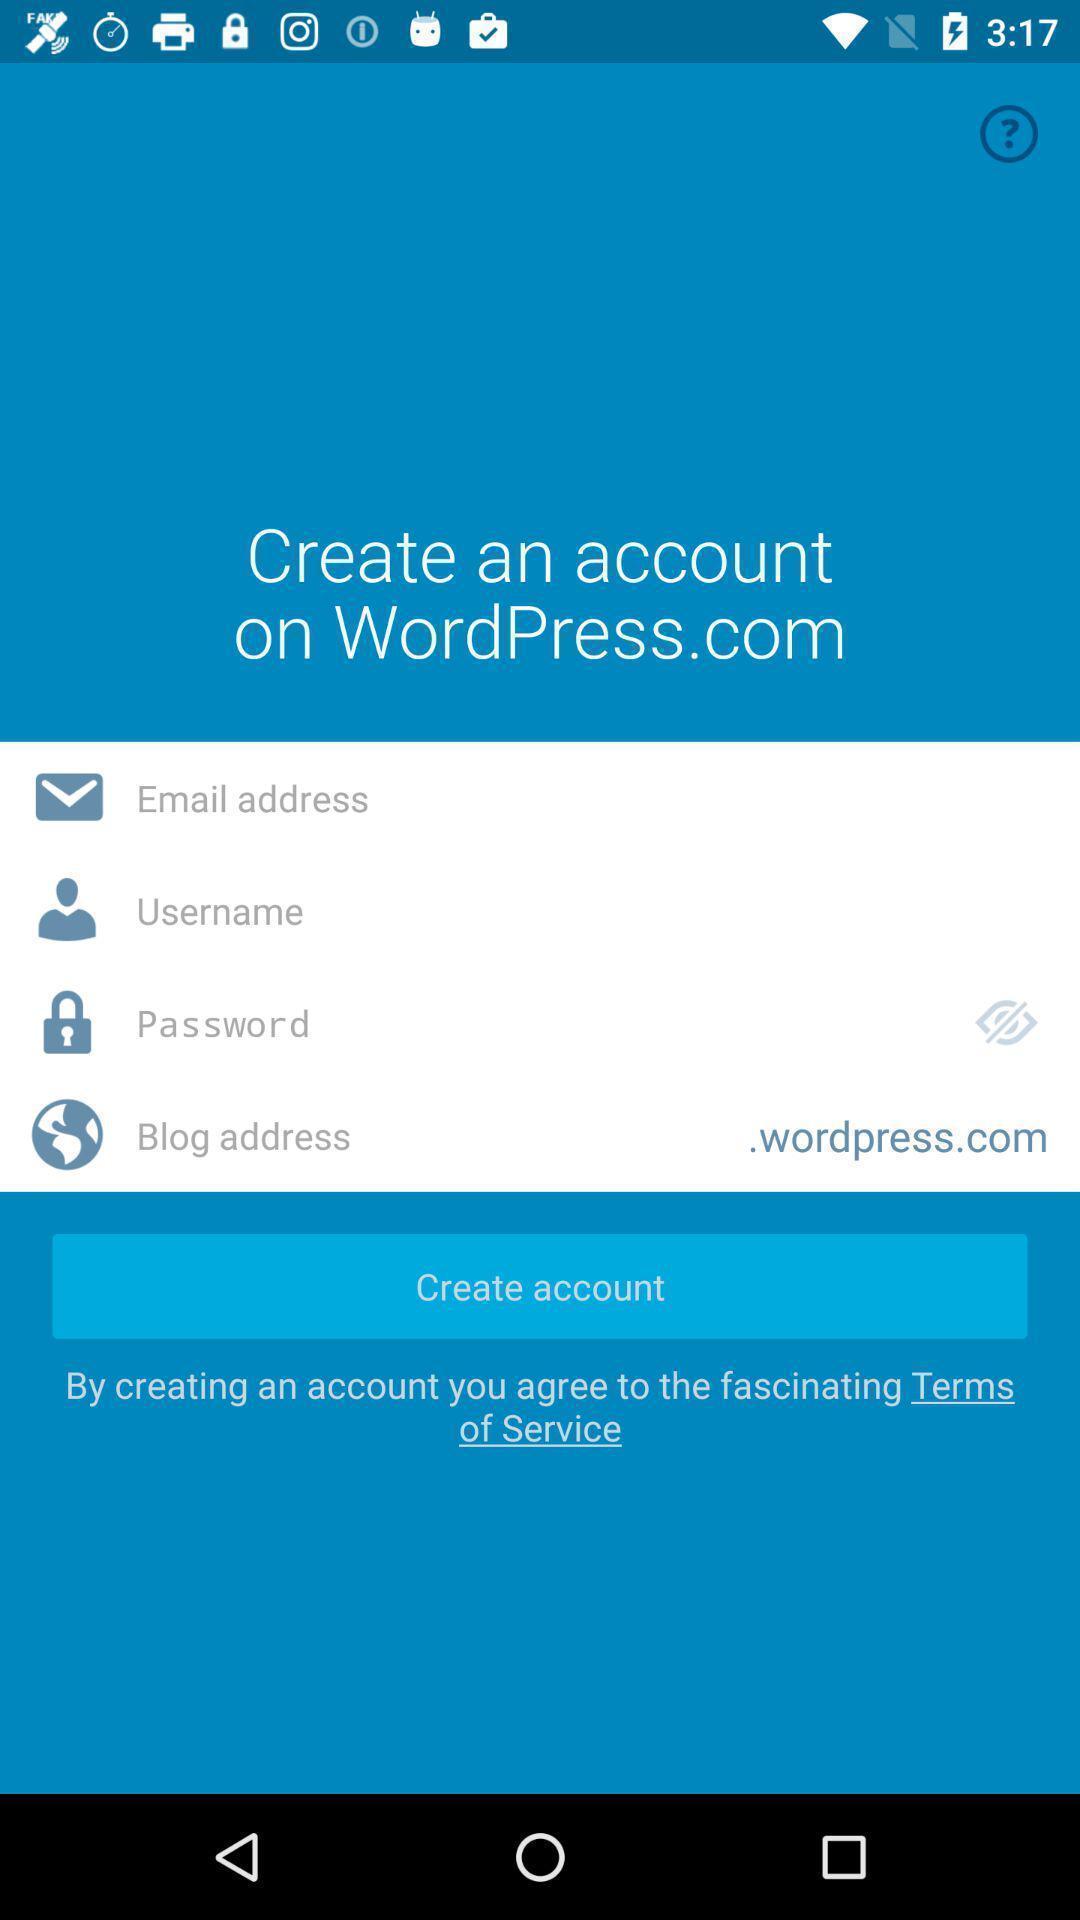Provide a textual representation of this image. Welcome page for an app. 